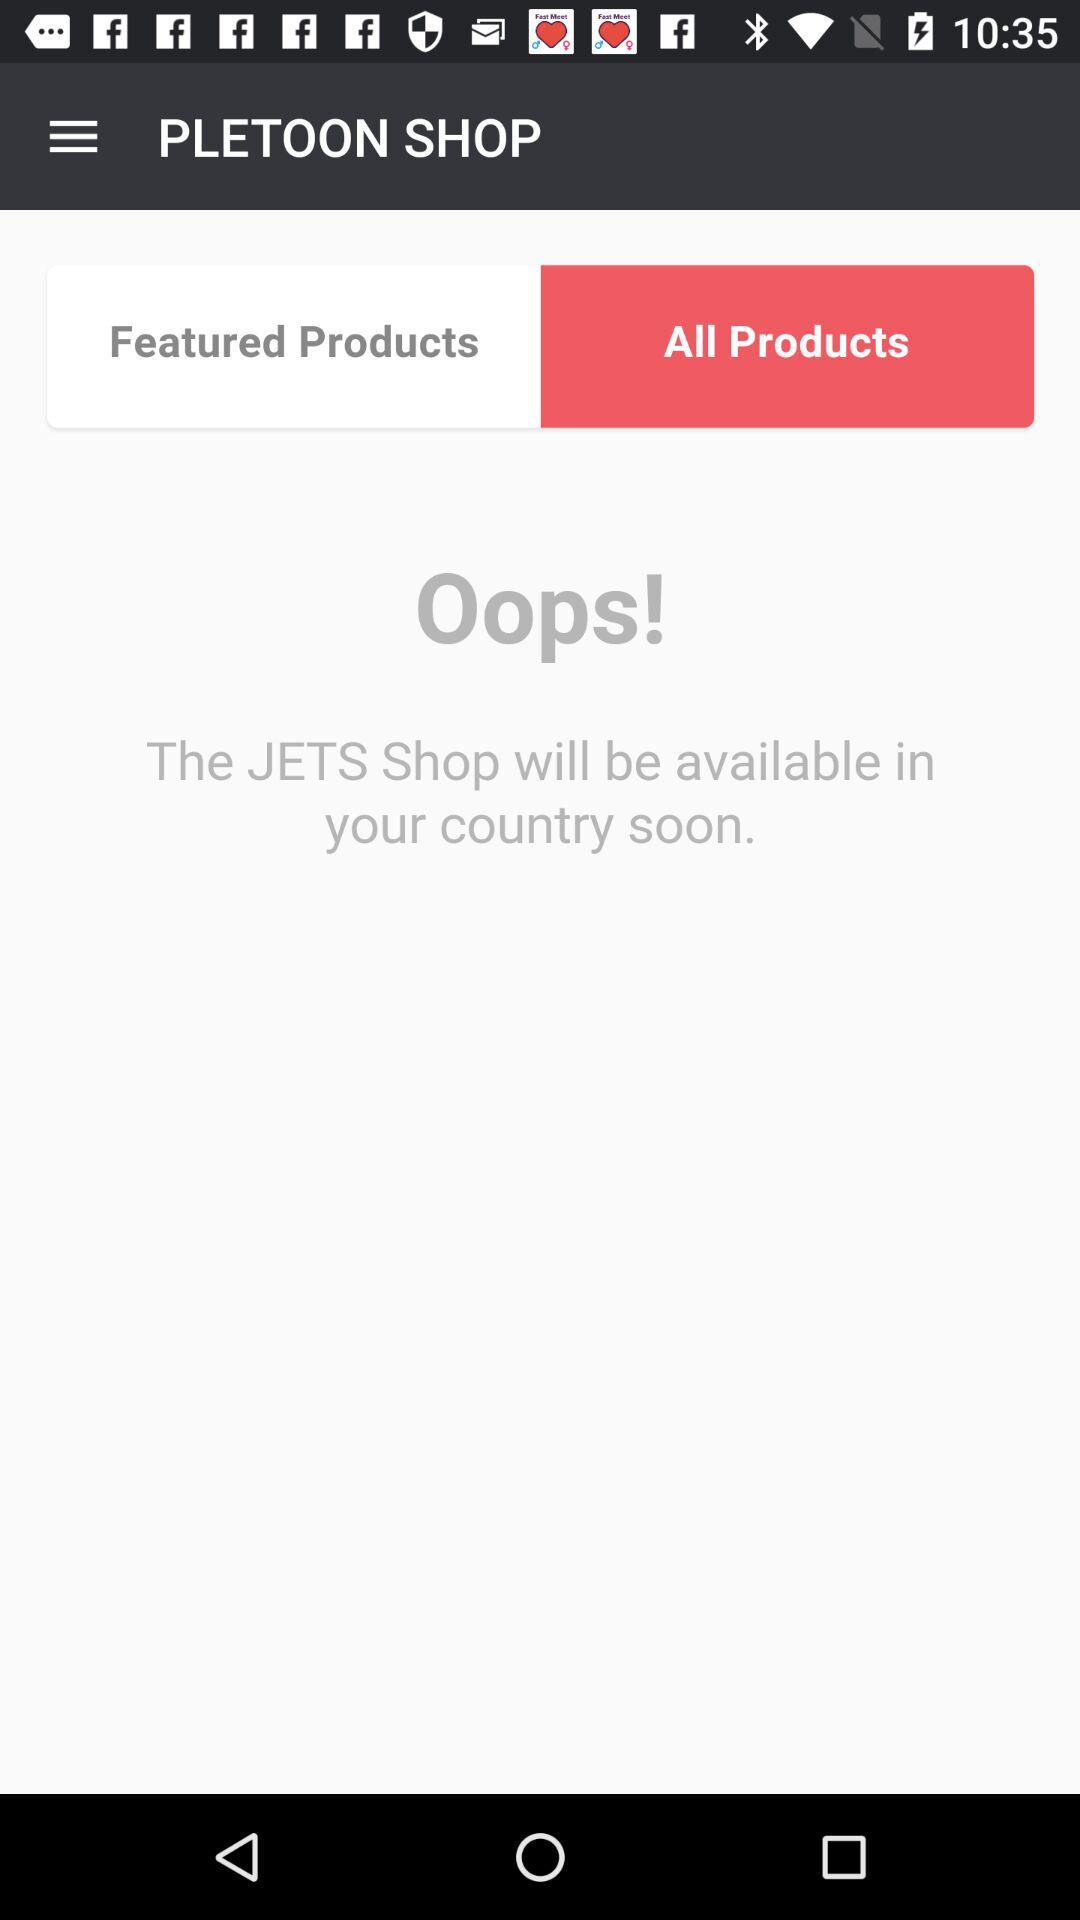What is the selected tab? The selected tab is "All Products". 